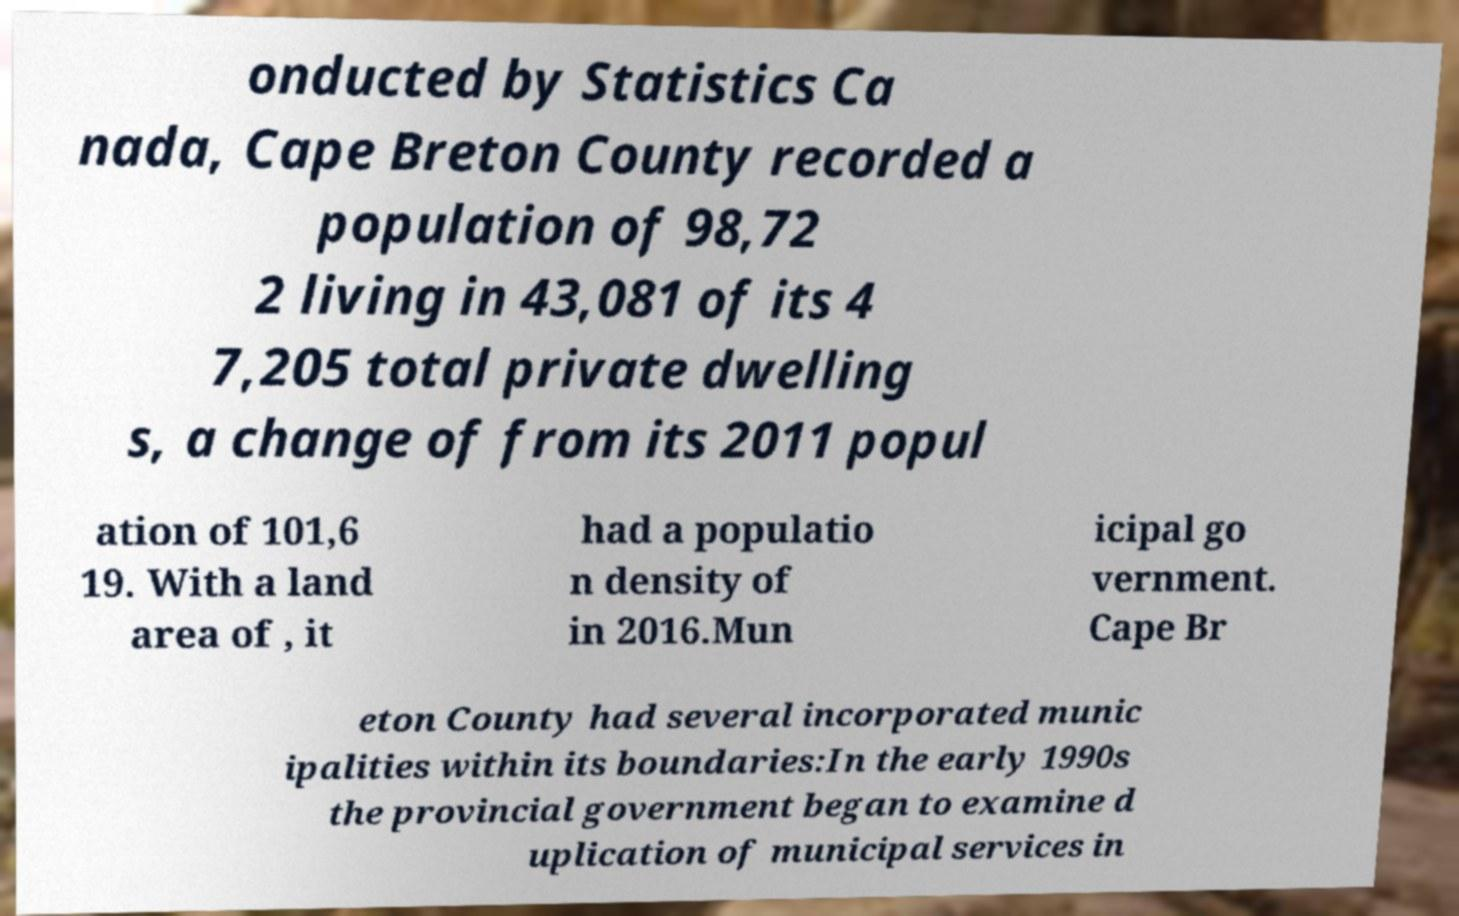Can you accurately transcribe the text from the provided image for me? onducted by Statistics Ca nada, Cape Breton County recorded a population of 98,72 2 living in 43,081 of its 4 7,205 total private dwelling s, a change of from its 2011 popul ation of 101,6 19. With a land area of , it had a populatio n density of in 2016.Mun icipal go vernment. Cape Br eton County had several incorporated munic ipalities within its boundaries:In the early 1990s the provincial government began to examine d uplication of municipal services in 